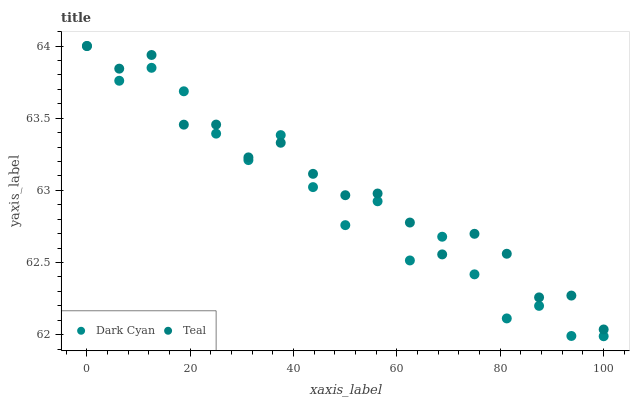Does Dark Cyan have the minimum area under the curve?
Answer yes or no. Yes. Does Teal have the maximum area under the curve?
Answer yes or no. Yes. Does Teal have the minimum area under the curve?
Answer yes or no. No. Is Teal the smoothest?
Answer yes or no. Yes. Is Dark Cyan the roughest?
Answer yes or no. Yes. Is Teal the roughest?
Answer yes or no. No. Does Dark Cyan have the lowest value?
Answer yes or no. Yes. Does Teal have the lowest value?
Answer yes or no. No. Does Teal have the highest value?
Answer yes or no. Yes. Does Teal intersect Dark Cyan?
Answer yes or no. Yes. Is Teal less than Dark Cyan?
Answer yes or no. No. Is Teal greater than Dark Cyan?
Answer yes or no. No. 